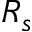Convert formula to latex. <formula><loc_0><loc_0><loc_500><loc_500>R _ { s }</formula> 